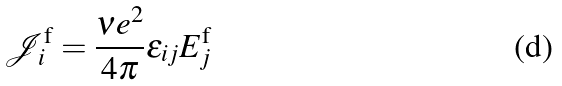Convert formula to latex. <formula><loc_0><loc_0><loc_500><loc_500>\mathcal { J } _ { i } ^ { \text {f} } = \frac { \nu e ^ { 2 } } { 4 \pi } \varepsilon _ { i j } E _ { j } ^ { \text {f} }</formula> 